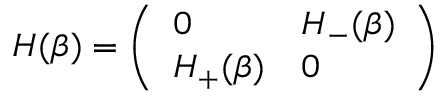<formula> <loc_0><loc_0><loc_500><loc_500>\begin{array} { r } { H ( \beta ) = \left ( \begin{array} { l l } { 0 } & { H _ { - } ( \beta ) } \\ { H _ { + } ( \beta ) } & { 0 } \end{array} \right ) } \end{array}</formula> 